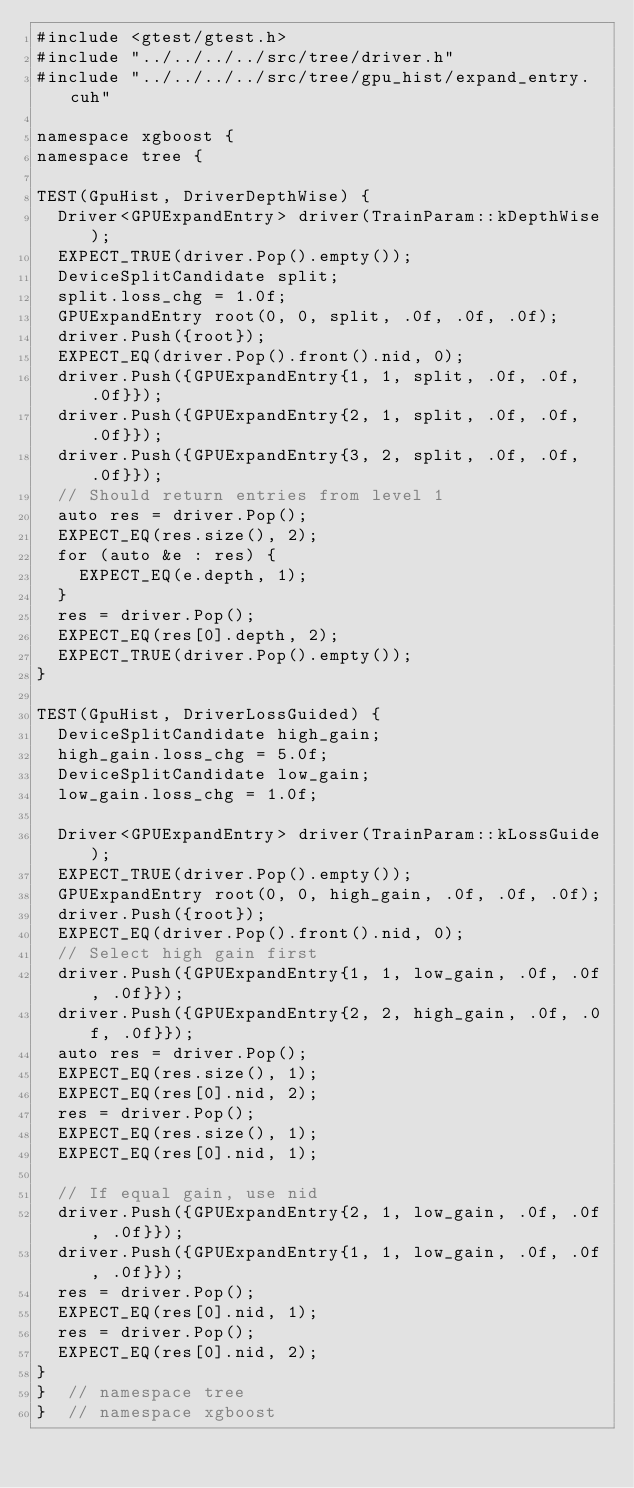Convert code to text. <code><loc_0><loc_0><loc_500><loc_500><_Cuda_>#include <gtest/gtest.h>
#include "../../../../src/tree/driver.h"
#include "../../../../src/tree/gpu_hist/expand_entry.cuh"

namespace xgboost {
namespace tree {

TEST(GpuHist, DriverDepthWise) {
  Driver<GPUExpandEntry> driver(TrainParam::kDepthWise);
  EXPECT_TRUE(driver.Pop().empty());
  DeviceSplitCandidate split;
  split.loss_chg = 1.0f;
  GPUExpandEntry root(0, 0, split, .0f, .0f, .0f);
  driver.Push({root});
  EXPECT_EQ(driver.Pop().front().nid, 0);
  driver.Push({GPUExpandEntry{1, 1, split, .0f, .0f, .0f}});
  driver.Push({GPUExpandEntry{2, 1, split, .0f, .0f, .0f}});
  driver.Push({GPUExpandEntry{3, 2, split, .0f, .0f, .0f}});
  // Should return entries from level 1
  auto res = driver.Pop();
  EXPECT_EQ(res.size(), 2);
  for (auto &e : res) {
    EXPECT_EQ(e.depth, 1);
  }
  res = driver.Pop();
  EXPECT_EQ(res[0].depth, 2);
  EXPECT_TRUE(driver.Pop().empty());
}

TEST(GpuHist, DriverLossGuided) {
  DeviceSplitCandidate high_gain;
  high_gain.loss_chg = 5.0f;
  DeviceSplitCandidate low_gain;
  low_gain.loss_chg = 1.0f;

  Driver<GPUExpandEntry> driver(TrainParam::kLossGuide);
  EXPECT_TRUE(driver.Pop().empty());
  GPUExpandEntry root(0, 0, high_gain, .0f, .0f, .0f);
  driver.Push({root});
  EXPECT_EQ(driver.Pop().front().nid, 0);
  // Select high gain first
  driver.Push({GPUExpandEntry{1, 1, low_gain, .0f, .0f, .0f}});
  driver.Push({GPUExpandEntry{2, 2, high_gain, .0f, .0f, .0f}});
  auto res = driver.Pop();
  EXPECT_EQ(res.size(), 1);
  EXPECT_EQ(res[0].nid, 2);
  res = driver.Pop();
  EXPECT_EQ(res.size(), 1);
  EXPECT_EQ(res[0].nid, 1);

  // If equal gain, use nid
  driver.Push({GPUExpandEntry{2, 1, low_gain, .0f, .0f, .0f}});
  driver.Push({GPUExpandEntry{1, 1, low_gain, .0f, .0f, .0f}});
  res = driver.Pop();
  EXPECT_EQ(res[0].nid, 1);
  res = driver.Pop();
  EXPECT_EQ(res[0].nid, 2);
}
}  // namespace tree
}  // namespace xgboost
</code> 